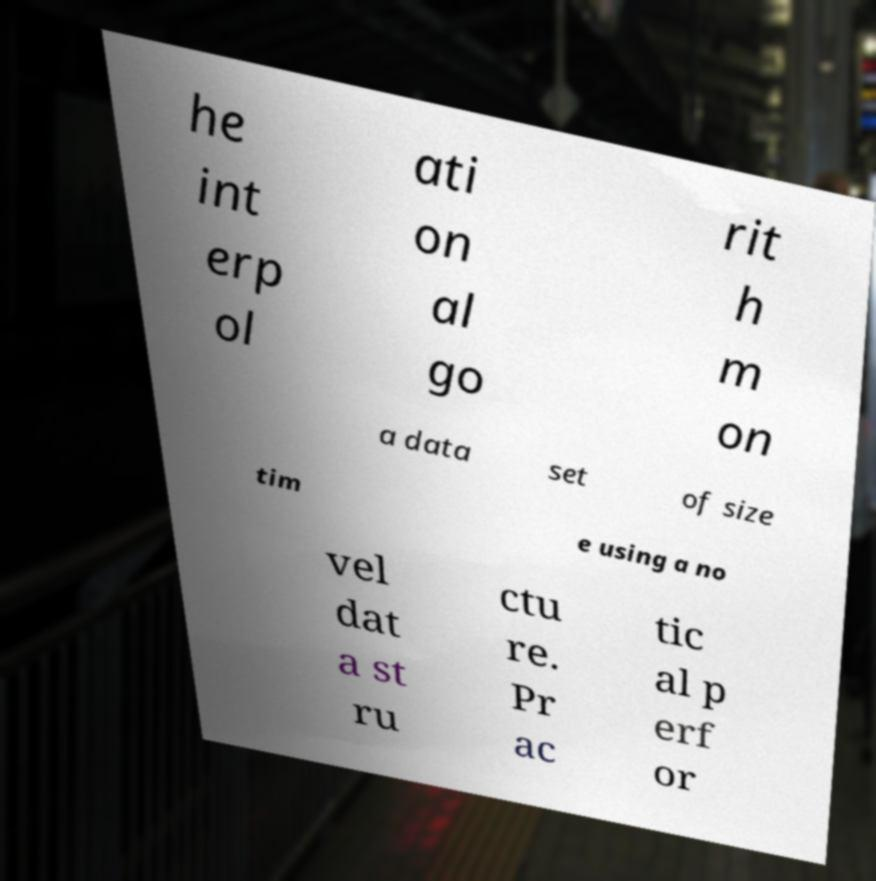I need the written content from this picture converted into text. Can you do that? he int erp ol ati on al go rit h m on a data set of size tim e using a no vel dat a st ru ctu re. Pr ac tic al p erf or 